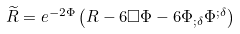Convert formula to latex. <formula><loc_0><loc_0><loc_500><loc_500>\widetilde { R } = e ^ { - 2 \Phi } \left ( R - 6 \square \Phi - 6 \Phi _ { ; \delta } \Phi ^ { ; \delta } \right )</formula> 